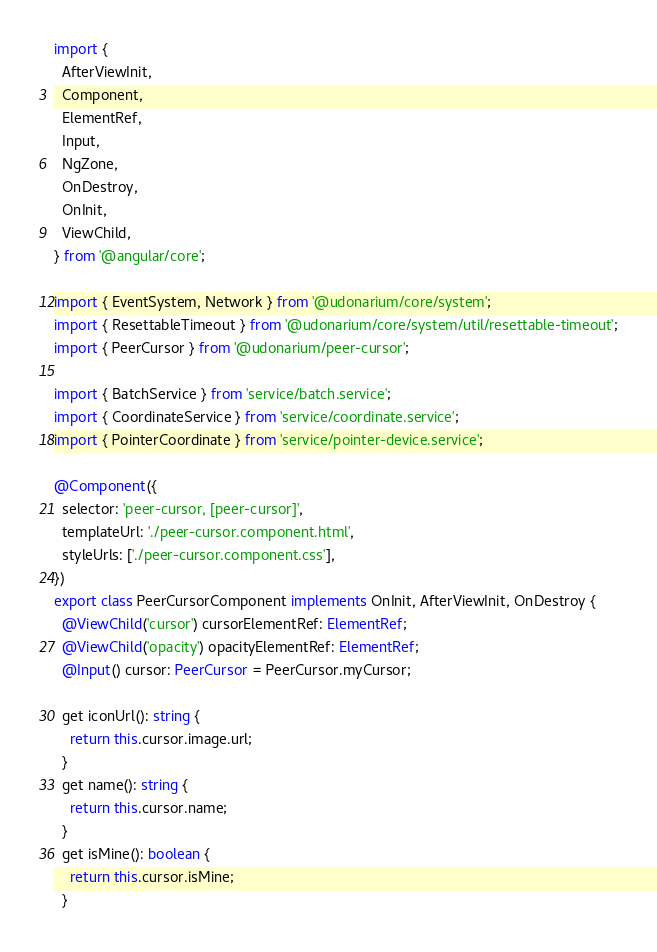Convert code to text. <code><loc_0><loc_0><loc_500><loc_500><_TypeScript_>import {
  AfterViewInit,
  Component,
  ElementRef,
  Input,
  NgZone,
  OnDestroy,
  OnInit,
  ViewChild,
} from '@angular/core';

import { EventSystem, Network } from '@udonarium/core/system';
import { ResettableTimeout } from '@udonarium/core/system/util/resettable-timeout';
import { PeerCursor } from '@udonarium/peer-cursor';

import { BatchService } from 'service/batch.service';
import { CoordinateService } from 'service/coordinate.service';
import { PointerCoordinate } from 'service/pointer-device.service';

@Component({
  selector: 'peer-cursor, [peer-cursor]',
  templateUrl: './peer-cursor.component.html',
  styleUrls: ['./peer-cursor.component.css'],
})
export class PeerCursorComponent implements OnInit, AfterViewInit, OnDestroy {
  @ViewChild('cursor') cursorElementRef: ElementRef;
  @ViewChild('opacity') opacityElementRef: ElementRef;
  @Input() cursor: PeerCursor = PeerCursor.myCursor;

  get iconUrl(): string {
    return this.cursor.image.url;
  }
  get name(): string {
    return this.cursor.name;
  }
  get isMine(): boolean {
    return this.cursor.isMine;
  }
</code> 